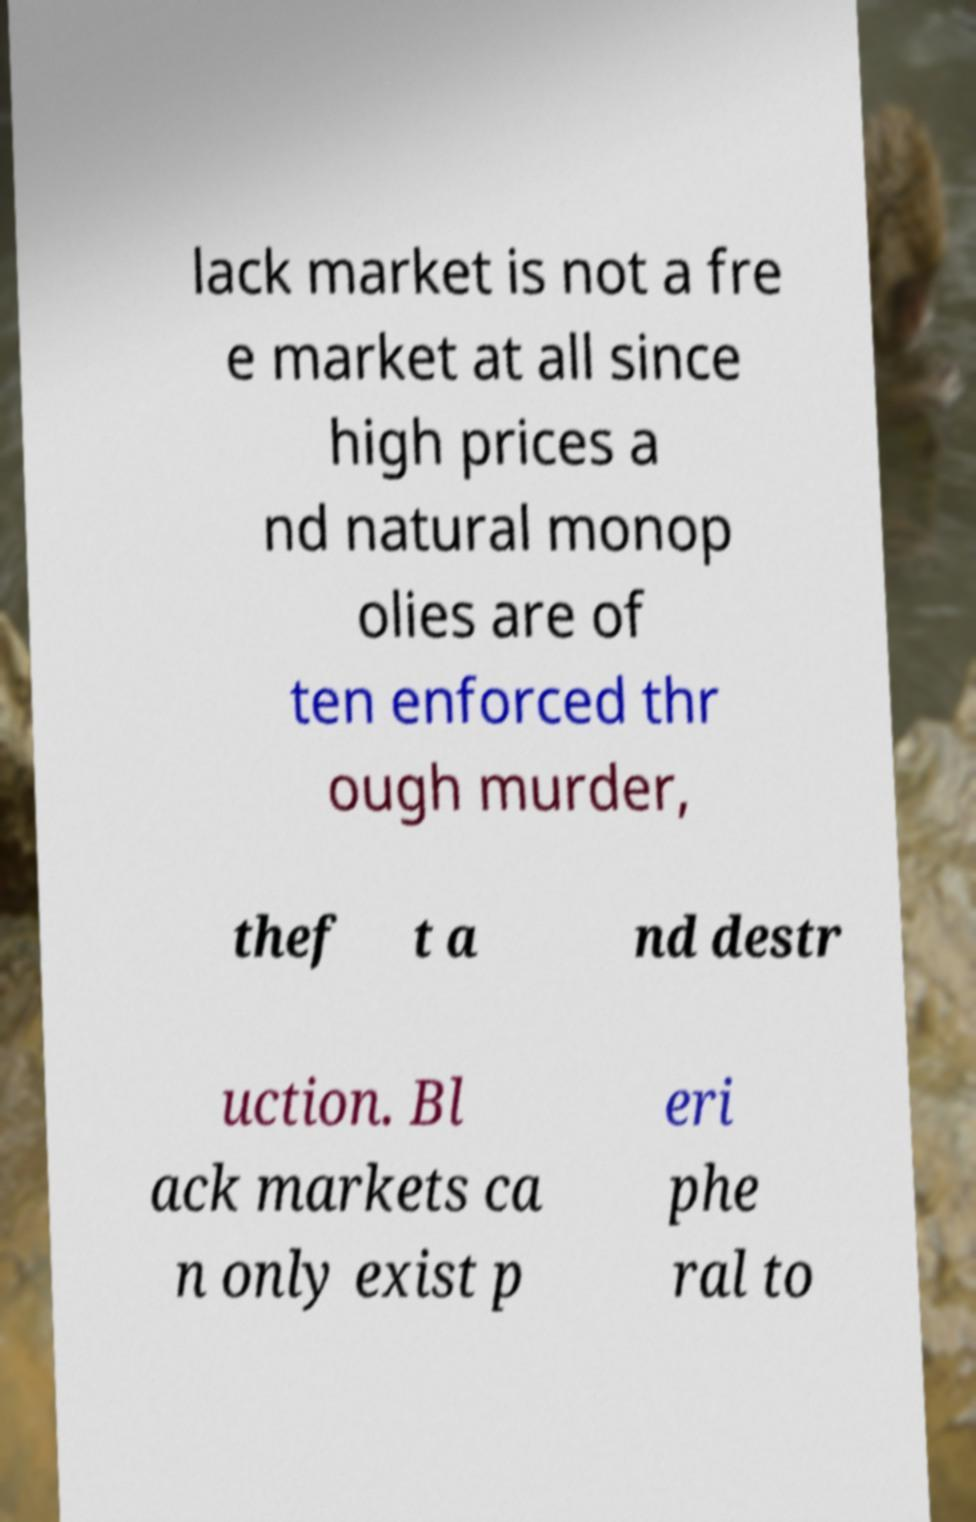Can you read and provide the text displayed in the image?This photo seems to have some interesting text. Can you extract and type it out for me? lack market is not a fre e market at all since high prices a nd natural monop olies are of ten enforced thr ough murder, thef t a nd destr uction. Bl ack markets ca n only exist p eri phe ral to 